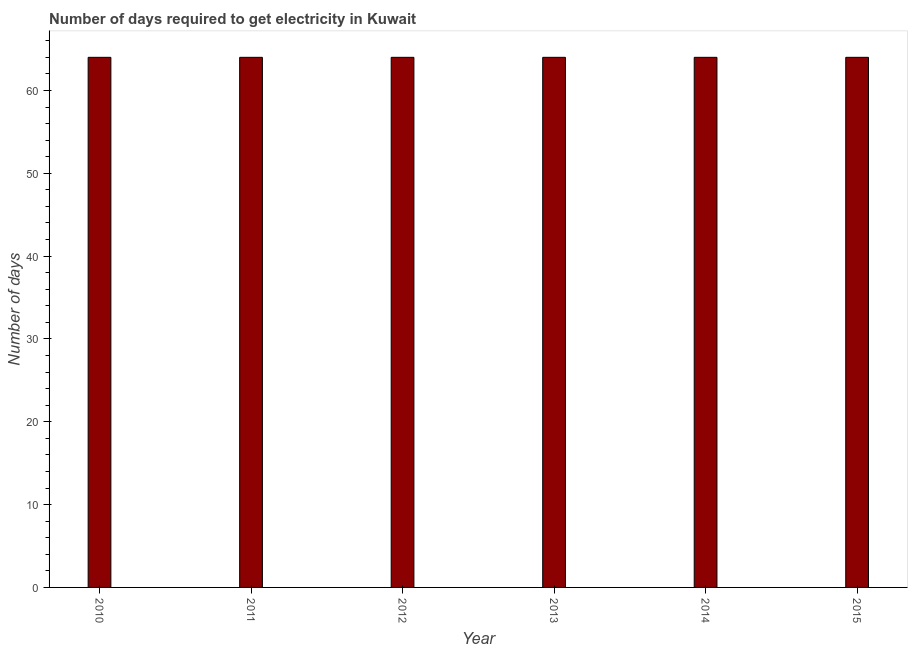Does the graph contain any zero values?
Ensure brevity in your answer.  No. What is the title of the graph?
Offer a terse response. Number of days required to get electricity in Kuwait. What is the label or title of the Y-axis?
Your response must be concise. Number of days. Across all years, what is the maximum time to get electricity?
Offer a very short reply. 64. In which year was the time to get electricity minimum?
Give a very brief answer. 2010. What is the sum of the time to get electricity?
Keep it short and to the point. 384. What is the median time to get electricity?
Your answer should be very brief. 64. Do a majority of the years between 2010 and 2012 (inclusive) have time to get electricity greater than 56 ?
Ensure brevity in your answer.  Yes. What is the ratio of the time to get electricity in 2011 to that in 2014?
Provide a succinct answer. 1. Is the time to get electricity in 2010 less than that in 2014?
Keep it short and to the point. No. What is the difference between the highest and the second highest time to get electricity?
Provide a succinct answer. 0. In how many years, is the time to get electricity greater than the average time to get electricity taken over all years?
Your answer should be very brief. 0. How many bars are there?
Keep it short and to the point. 6. Are all the bars in the graph horizontal?
Your answer should be very brief. No. How many years are there in the graph?
Your answer should be very brief. 6. What is the difference between two consecutive major ticks on the Y-axis?
Offer a terse response. 10. Are the values on the major ticks of Y-axis written in scientific E-notation?
Provide a short and direct response. No. What is the Number of days in 2011?
Keep it short and to the point. 64. What is the Number of days of 2013?
Provide a short and direct response. 64. What is the Number of days of 2015?
Offer a very short reply. 64. What is the difference between the Number of days in 2010 and 2011?
Provide a succinct answer. 0. What is the difference between the Number of days in 2010 and 2013?
Your answer should be very brief. 0. What is the difference between the Number of days in 2010 and 2015?
Your response must be concise. 0. What is the difference between the Number of days in 2011 and 2012?
Provide a succinct answer. 0. What is the difference between the Number of days in 2011 and 2013?
Your answer should be compact. 0. What is the difference between the Number of days in 2011 and 2015?
Ensure brevity in your answer.  0. What is the difference between the Number of days in 2014 and 2015?
Your response must be concise. 0. What is the ratio of the Number of days in 2010 to that in 2011?
Your answer should be very brief. 1. What is the ratio of the Number of days in 2010 to that in 2013?
Provide a succinct answer. 1. What is the ratio of the Number of days in 2011 to that in 2013?
Offer a terse response. 1. What is the ratio of the Number of days in 2011 to that in 2015?
Your response must be concise. 1. What is the ratio of the Number of days in 2012 to that in 2013?
Your response must be concise. 1. What is the ratio of the Number of days in 2013 to that in 2014?
Provide a short and direct response. 1. What is the ratio of the Number of days in 2014 to that in 2015?
Your response must be concise. 1. 